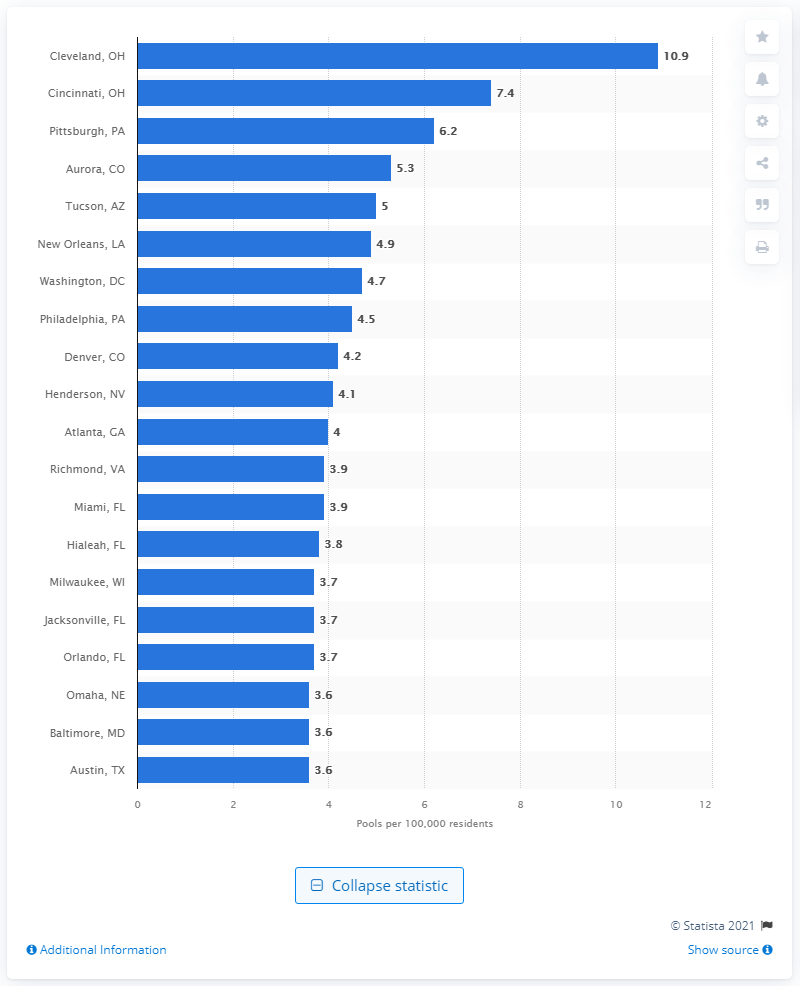Point out several critical features in this image. In 2020, there were 6.2 public swimming pools in Pittsburgh. 